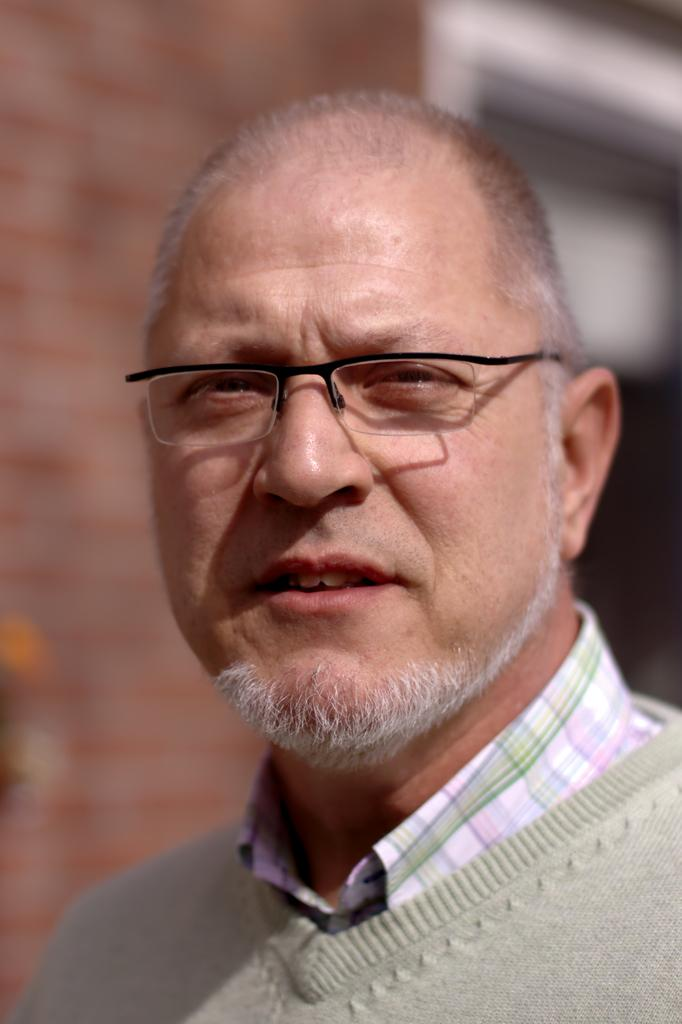What can be seen on the person's face in the image? The person in the image is wearing spectacles. What direction is the person looking in the image? The person is looking forward. How would you describe the background of the image? The background of the image is blurry. What type of structure can be seen in the background of the image? There is a wall visible in the background of the image. What type of part is being whistled by the person in the image? There is no indication in the image that the person is whistling or that any part is being whistled. 